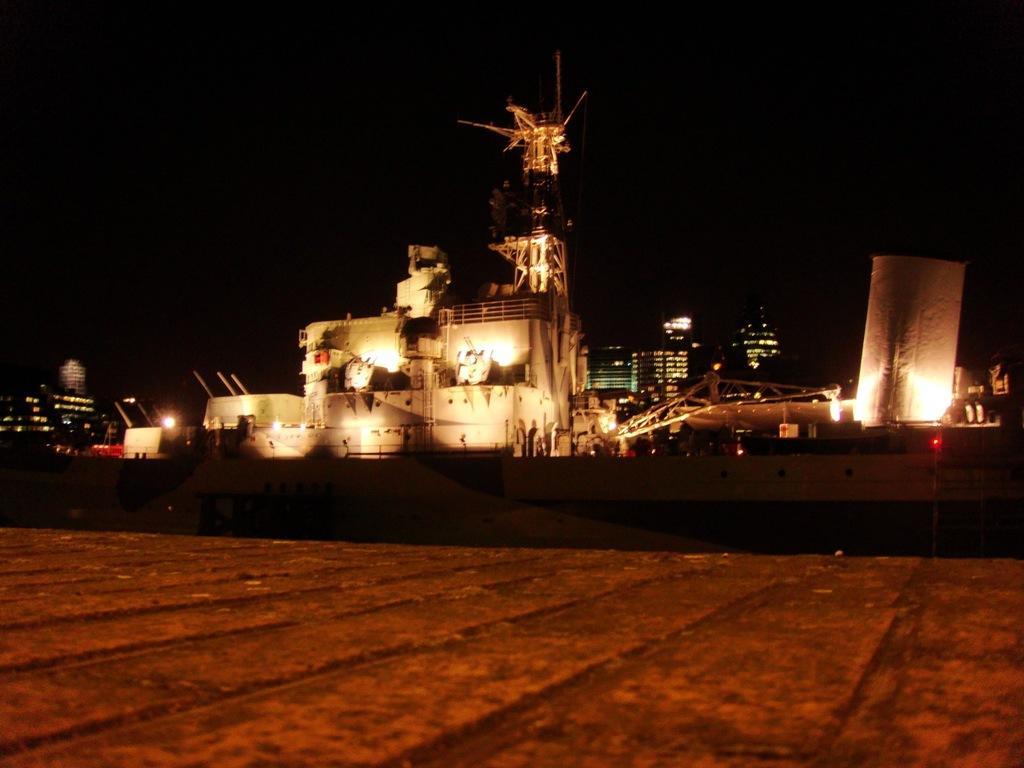Please provide a concise description of this image. In this image we can see ship. Behind the ship, buildings are there. At the bottom of the image, we can see land. 